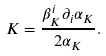Convert formula to latex. <formula><loc_0><loc_0><loc_500><loc_500>K = \frac { \beta _ { K } ^ { i } \partial _ { i } \alpha _ { K } } { 2 \alpha _ { K } } .</formula> 